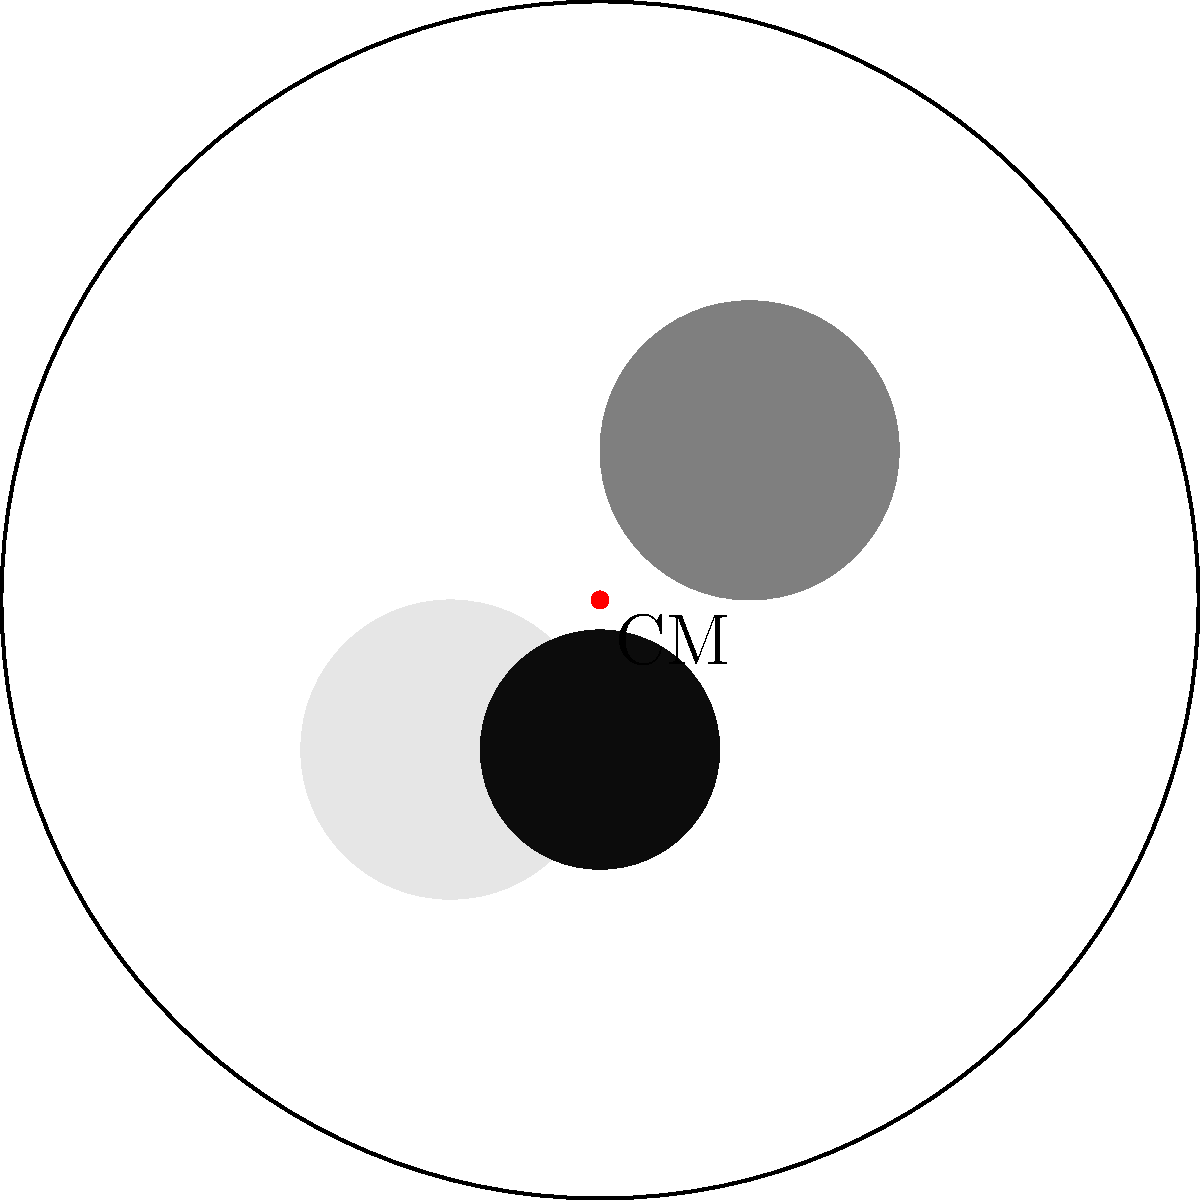A waitress at your local diner is carrying a balanced plate of food. If the plate remains level while she walks, what can you conclude about the position of the center of mass of the plate and food combination? To understand this situation, let's break it down step-by-step:

1. The center of mass (CM) is the point where the entire mass of an object can be considered to be concentrated for the purpose of calculating its rotational effects.

2. For a plate to remain level while being carried, the gravitational force must act through a point directly above the support (the waitress's hand).

3. If the plate tilts, it means the CM is not aligned with the support, causing a torque that would rotate the plate.

4. Since the plate remains level, we can conclude that no net torque is acting on the plate-food system.

5. This is only possible if the CM of the entire system (plate + food) is located directly above the point of support.

6. In a balanced situation, the CM must be along the vertical line passing through the point where the waitress is holding the plate.

7. Given that the plate is horizontal, the CM must be somewhere along the vertical axis passing through the center of the plate.

Therefore, for the plate to remain level, the CM of the plate-food system must be located directly above the center of the plate's bottom surface, where the waitress is likely supporting it.
Answer: The center of mass is directly above the plate's center. 